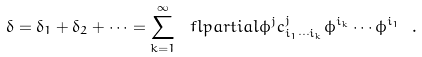<formula> <loc_0><loc_0><loc_500><loc_500>\delta = \delta _ { 1 } + \delta _ { 2 } + \cdots = \sum _ { k = 1 } ^ { \infty } \ f l p a r t i a l { \phi ^ { j } } c ^ { j } _ { i _ { 1 } \cdots i _ { k } } \phi ^ { i _ { k } } \cdots \phi ^ { i _ { 1 } } \ .</formula> 